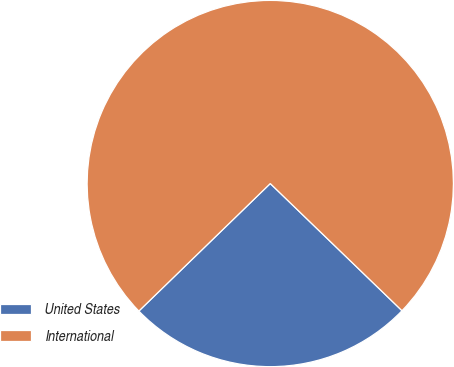Convert chart. <chart><loc_0><loc_0><loc_500><loc_500><pie_chart><fcel>United States<fcel>International<nl><fcel>25.52%<fcel>74.48%<nl></chart> 